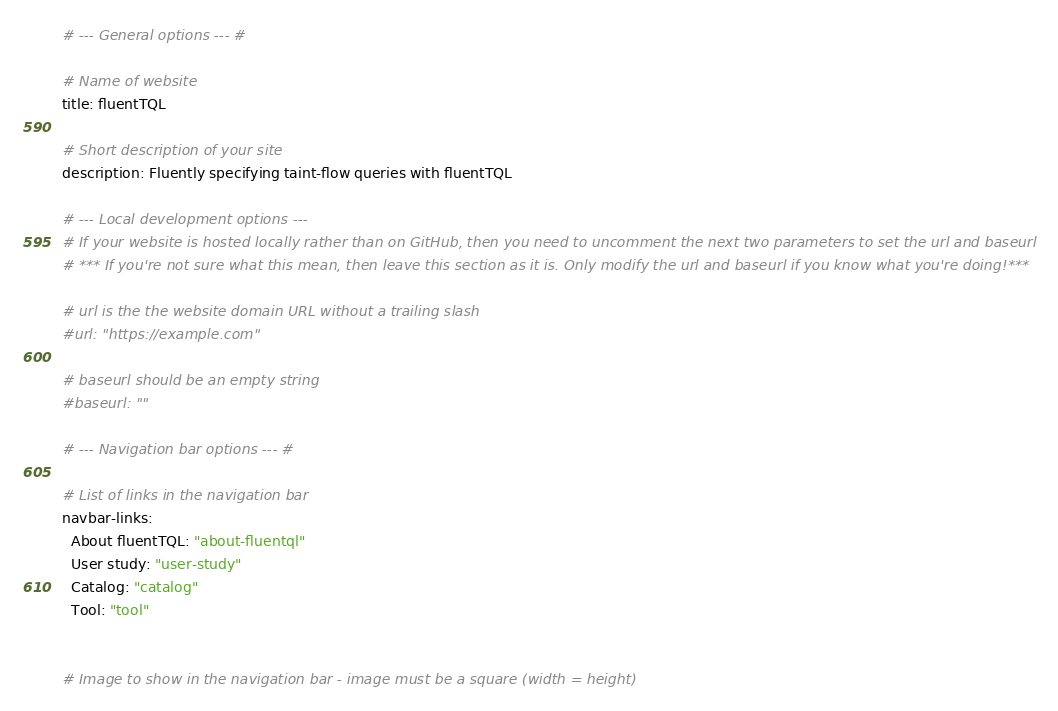<code> <loc_0><loc_0><loc_500><loc_500><_YAML_># --- General options --- #

# Name of website
title: fluentTQL

# Short description of your site
description: Fluently specifying taint-flow queries with fluentTQL

# --- Local development options ---
# If your website is hosted locally rather than on GitHub, then you need to uncomment the next two parameters to set the url and baseurl
# *** If you're not sure what this mean, then leave this section as it is. Only modify the url and baseurl if you know what you're doing!***

# url is the the website domain URL without a trailing slash
#url: "https://example.com"

# baseurl should be an empty string
#baseurl: ""

# --- Navigation bar options --- #

# List of links in the navigation bar
navbar-links:
  About fluentTQL: "about-fluentql"
  User study: "user-study"
  Catalog: "catalog"
  Tool: "tool"
  

# Image to show in the navigation bar - image must be a square (width = height)</code> 